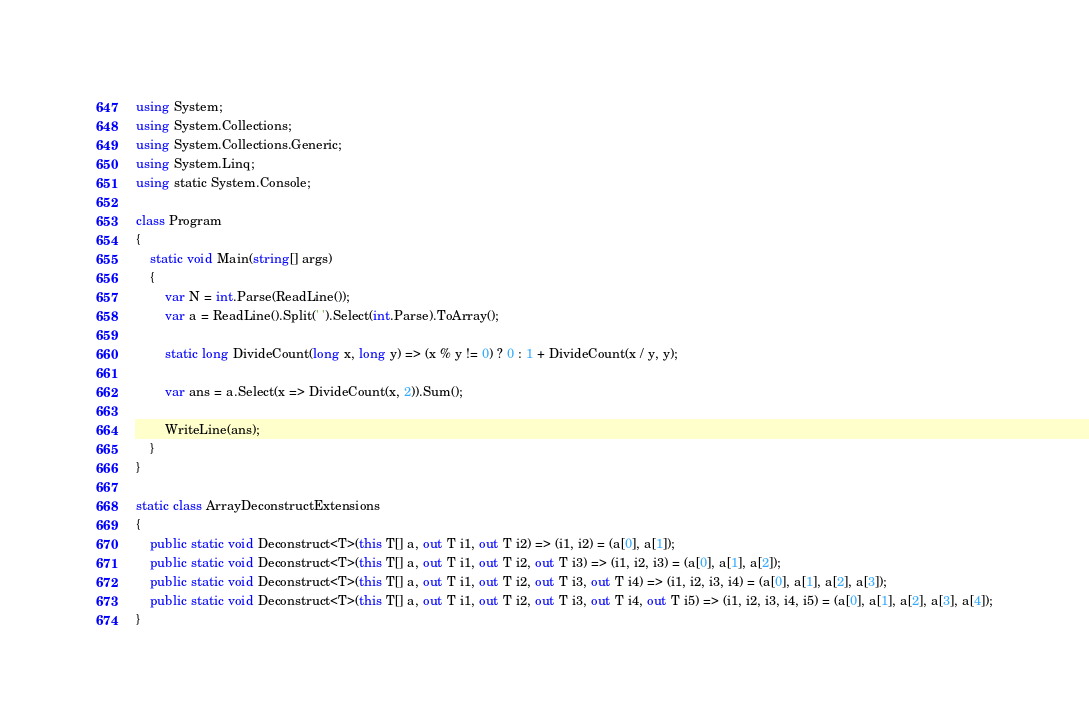<code> <loc_0><loc_0><loc_500><loc_500><_C#_>using System;
using System.Collections;
using System.Collections.Generic;
using System.Linq;
using static System.Console;

class Program
{
    static void Main(string[] args)
    {
        var N = int.Parse(ReadLine());
        var a = ReadLine().Split(' ').Select(int.Parse).ToArray();

        static long DivideCount(long x, long y) => (x % y != 0) ? 0 : 1 + DivideCount(x / y, y);

        var ans = a.Select(x => DivideCount(x, 2)).Sum();

        WriteLine(ans);
    }
}

static class ArrayDeconstructExtensions
{
    public static void Deconstruct<T>(this T[] a, out T i1, out T i2) => (i1, i2) = (a[0], a[1]);
    public static void Deconstruct<T>(this T[] a, out T i1, out T i2, out T i3) => (i1, i2, i3) = (a[0], a[1], a[2]);
    public static void Deconstruct<T>(this T[] a, out T i1, out T i2, out T i3, out T i4) => (i1, i2, i3, i4) = (a[0], a[1], a[2], a[3]);
    public static void Deconstruct<T>(this T[] a, out T i1, out T i2, out T i3, out T i4, out T i5) => (i1, i2, i3, i4, i5) = (a[0], a[1], a[2], a[3], a[4]);
}
</code> 